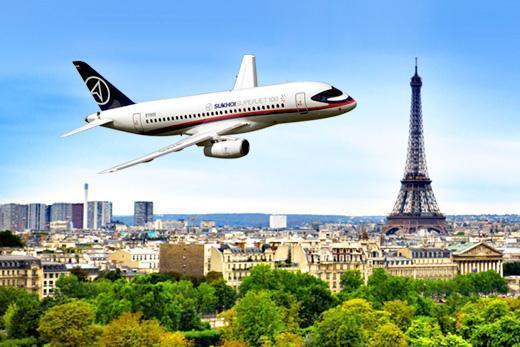How many people are cutting cake in the image?
Give a very brief answer. 0. 